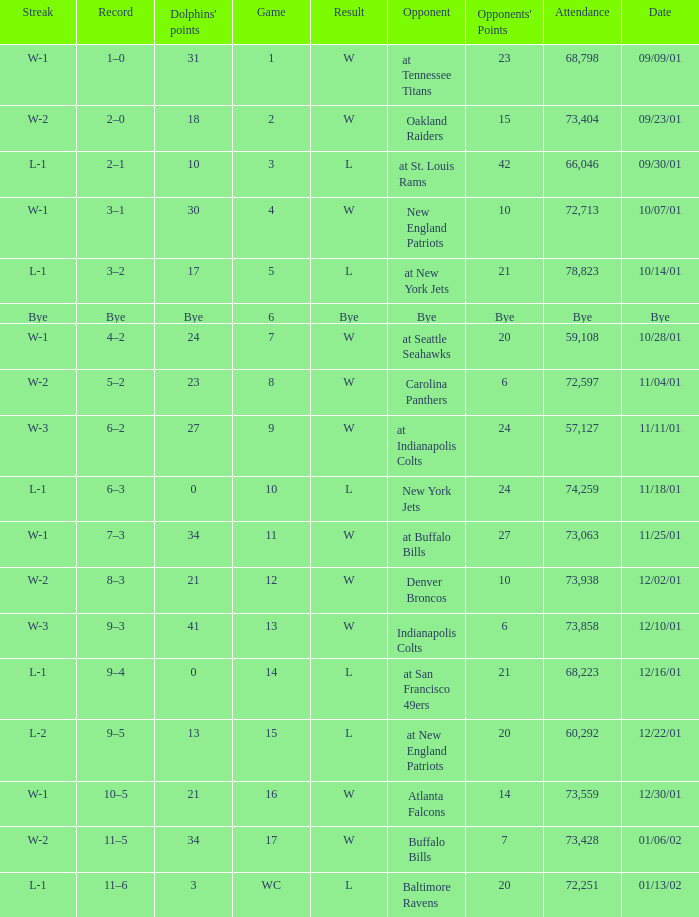What is the streak for game 2? W-2. 